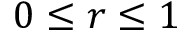<formula> <loc_0><loc_0><loc_500><loc_500>0 \leq r \leq 1</formula> 